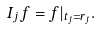Convert formula to latex. <formula><loc_0><loc_0><loc_500><loc_500>I _ { j } f = f | _ { t _ { j } = r _ { j } } .</formula> 